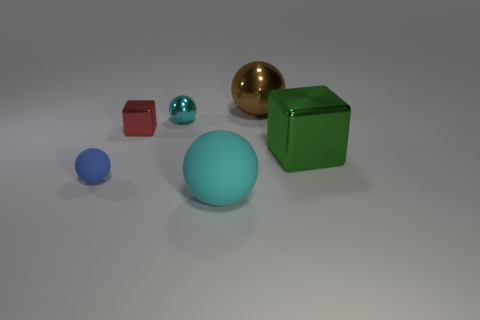There is a metal cube to the left of the large sphere that is behind the small blue matte thing; what is its color?
Your answer should be compact. Red. Is the color of the block on the left side of the big green cube the same as the large matte object?
Provide a succinct answer. No. Do the cyan matte ball and the brown object have the same size?
Your response must be concise. Yes. What shape is the matte thing that is the same size as the brown sphere?
Your response must be concise. Sphere. There is a cube that is to the right of the brown ball; is it the same size as the small cyan ball?
Keep it short and to the point. No. There is a brown ball that is the same size as the green metallic object; what is its material?
Provide a short and direct response. Metal. Are there any brown spheres behind the large shiny thing behind the metal thing on the right side of the brown object?
Give a very brief answer. No. Are there any other things that are the same shape as the cyan metallic object?
Offer a terse response. Yes. There is a small metallic object that is in front of the tiny cyan shiny thing; does it have the same color as the rubber object that is in front of the small blue rubber sphere?
Ensure brevity in your answer.  No. Is there a small cyan rubber object?
Make the answer very short. No. 